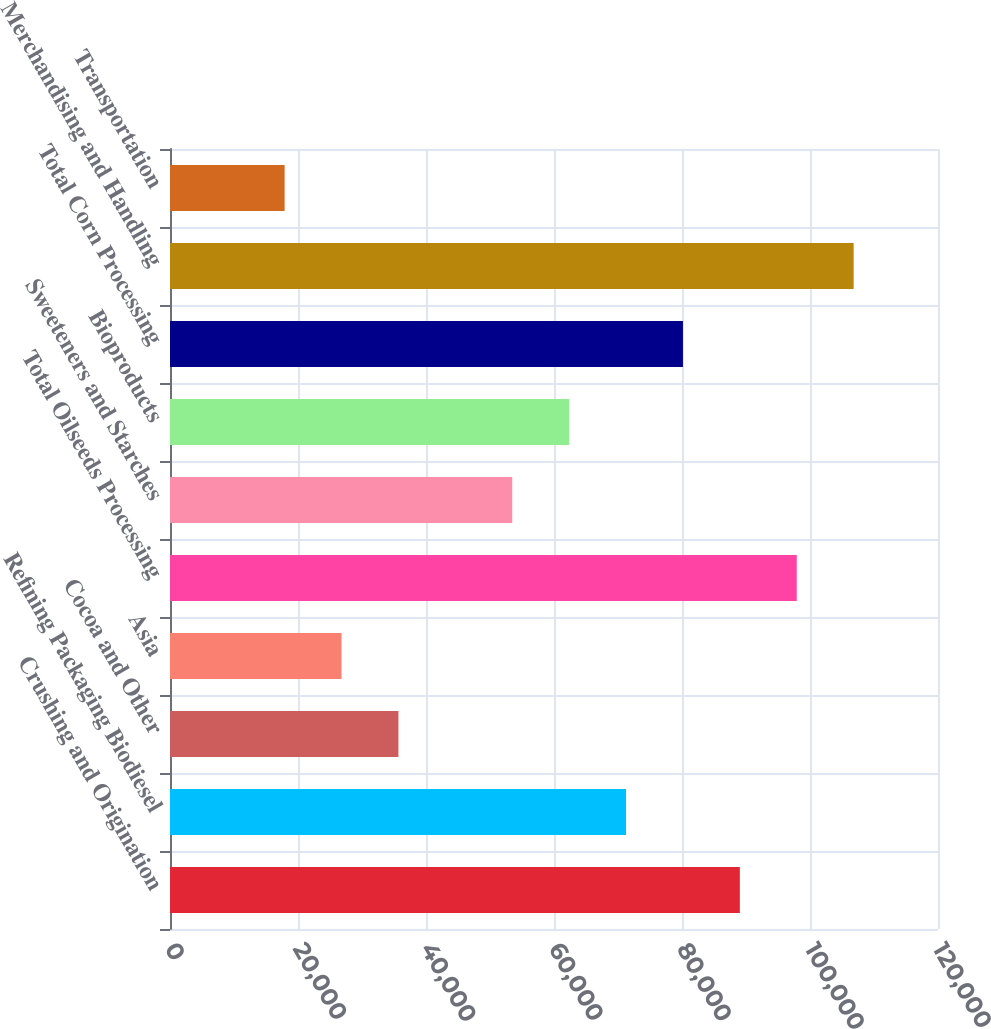Convert chart. <chart><loc_0><loc_0><loc_500><loc_500><bar_chart><fcel>Crushing and Origination<fcel>Refining Packaging Biodiesel<fcel>Cocoa and Other<fcel>Asia<fcel>Total Oilseeds Processing<fcel>Sweeteners and Starches<fcel>Bioproducts<fcel>Total Corn Processing<fcel>Merchandising and Handling<fcel>Transportation<nl><fcel>89038<fcel>71255.8<fcel>35691.4<fcel>26800.3<fcel>97929.1<fcel>53473.6<fcel>62364.7<fcel>80146.9<fcel>106820<fcel>17909.2<nl></chart> 